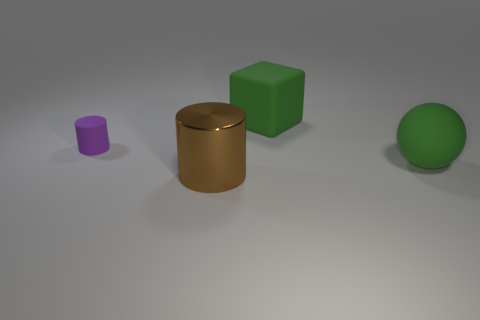Add 4 cyan rubber objects. How many objects exist? 8 Subtract 0 red balls. How many objects are left? 4 Subtract all green rubber things. Subtract all tiny purple matte things. How many objects are left? 1 Add 3 small cylinders. How many small cylinders are left? 4 Add 2 green things. How many green things exist? 4 